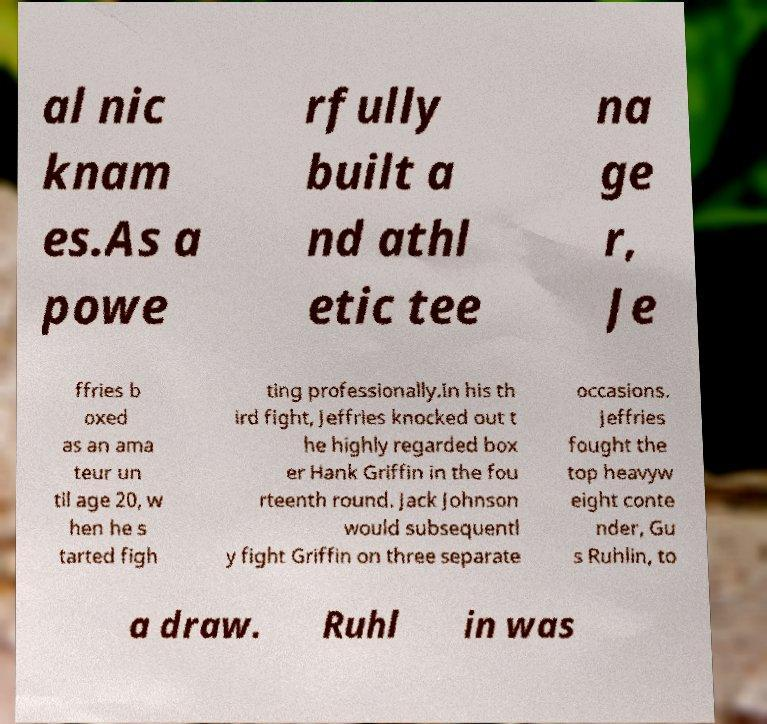Can you read and provide the text displayed in the image?This photo seems to have some interesting text. Can you extract and type it out for me? al nic knam es.As a powe rfully built a nd athl etic tee na ge r, Je ffries b oxed as an ama teur un til age 20, w hen he s tarted figh ting professionally.In his th ird fight, Jeffries knocked out t he highly regarded box er Hank Griffin in the fou rteenth round. Jack Johnson would subsequentl y fight Griffin on three separate occasions. Jeffries fought the top heavyw eight conte nder, Gu s Ruhlin, to a draw. Ruhl in was 